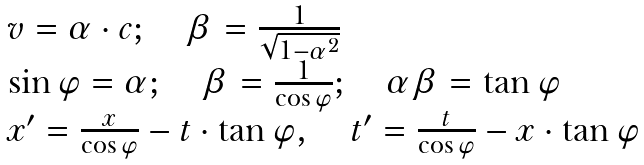Convert formula to latex. <formula><loc_0><loc_0><loc_500><loc_500>\begin{array} { l } { v = \alpha \cdot c ; \quad \beta = { \frac { 1 } { \sqrt { 1 - \alpha ^ { 2 } } } } } \\ { \sin \varphi = \alpha ; \quad \beta = { \frac { 1 } { \cos \varphi } } ; \quad \alpha \beta = \tan \varphi } \\ { x ^ { \prime } = { \frac { x } { \cos \varphi } } - t \cdot \tan \varphi , \quad t ^ { \prime } = { \frac { t } { \cos \varphi } } - x \cdot \tan \varphi } \end{array}</formula> 